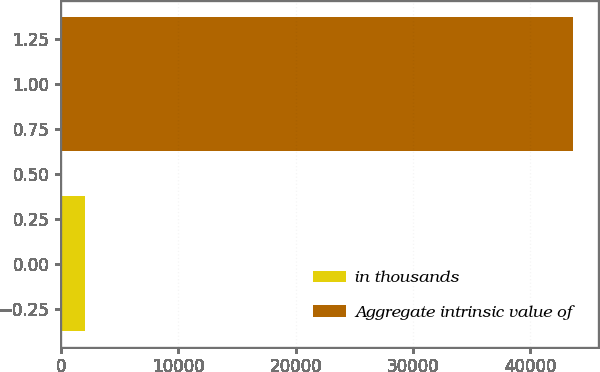<chart> <loc_0><loc_0><loc_500><loc_500><bar_chart><fcel>in thousands<fcel>Aggregate intrinsic value of<nl><fcel>2015<fcel>43620<nl></chart> 